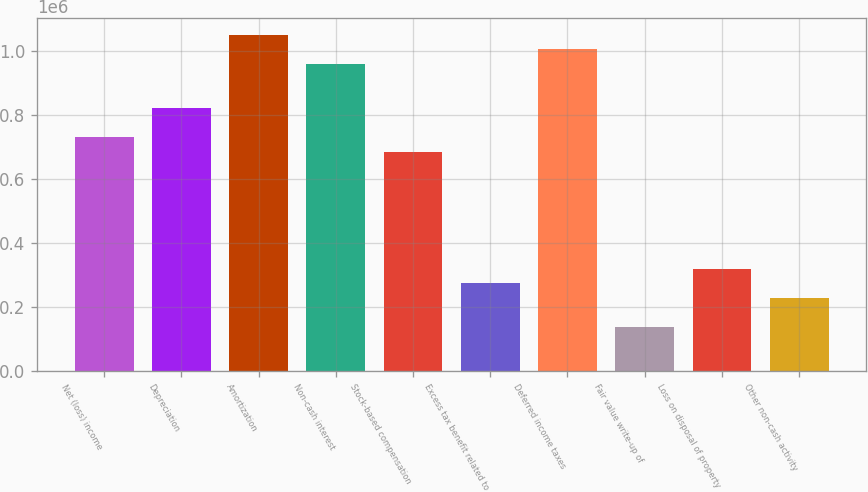Convert chart. <chart><loc_0><loc_0><loc_500><loc_500><bar_chart><fcel>Net (loss) income<fcel>Depreciation<fcel>Amortization<fcel>Non-cash interest<fcel>Stock-based compensation<fcel>Excess tax benefit related to<fcel>Deferred income taxes<fcel>Fair value write-up of<fcel>Loss on disposal of property<fcel>Other non-cash activity<nl><fcel>730724<fcel>822061<fcel>1.0504e+06<fcel>959067<fcel>685055<fcel>274038<fcel>1.00474e+06<fcel>137032<fcel>319706<fcel>228369<nl></chart> 